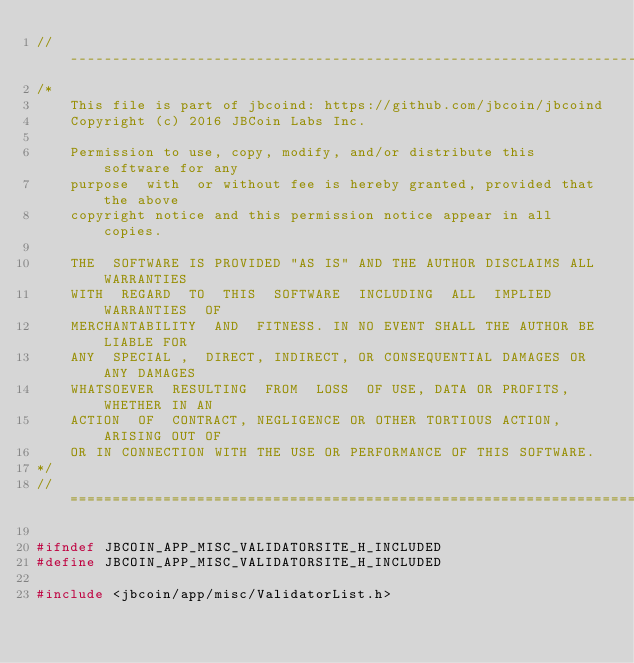Convert code to text. <code><loc_0><loc_0><loc_500><loc_500><_C_>//------------------------------------------------------------------------------
/*
    This file is part of jbcoind: https://github.com/jbcoin/jbcoind
    Copyright (c) 2016 JBCoin Labs Inc.

    Permission to use, copy, modify, and/or distribute this software for any
    purpose  with  or without fee is hereby granted, provided that the above
    copyright notice and this permission notice appear in all copies.

    THE  SOFTWARE IS PROVIDED "AS IS" AND THE AUTHOR DISCLAIMS ALL WARRANTIES
    WITH  REGARD  TO  THIS  SOFTWARE  INCLUDING  ALL  IMPLIED  WARRANTIES  OF
    MERCHANTABILITY  AND  FITNESS. IN NO EVENT SHALL THE AUTHOR BE LIABLE FOR
    ANY  SPECIAL ,  DIRECT, INDIRECT, OR CONSEQUENTIAL DAMAGES OR ANY DAMAGES
    WHATSOEVER  RESULTING  FROM  LOSS  OF USE, DATA OR PROFITS, WHETHER IN AN
    ACTION  OF  CONTRACT, NEGLIGENCE OR OTHER TORTIOUS ACTION, ARISING OUT OF
    OR IN CONNECTION WITH THE USE OR PERFORMANCE OF THIS SOFTWARE.
*/
//==============================================================================

#ifndef JBCOIN_APP_MISC_VALIDATORSITE_H_INCLUDED
#define JBCOIN_APP_MISC_VALIDATORSITE_H_INCLUDED

#include <jbcoin/app/misc/ValidatorList.h></code> 